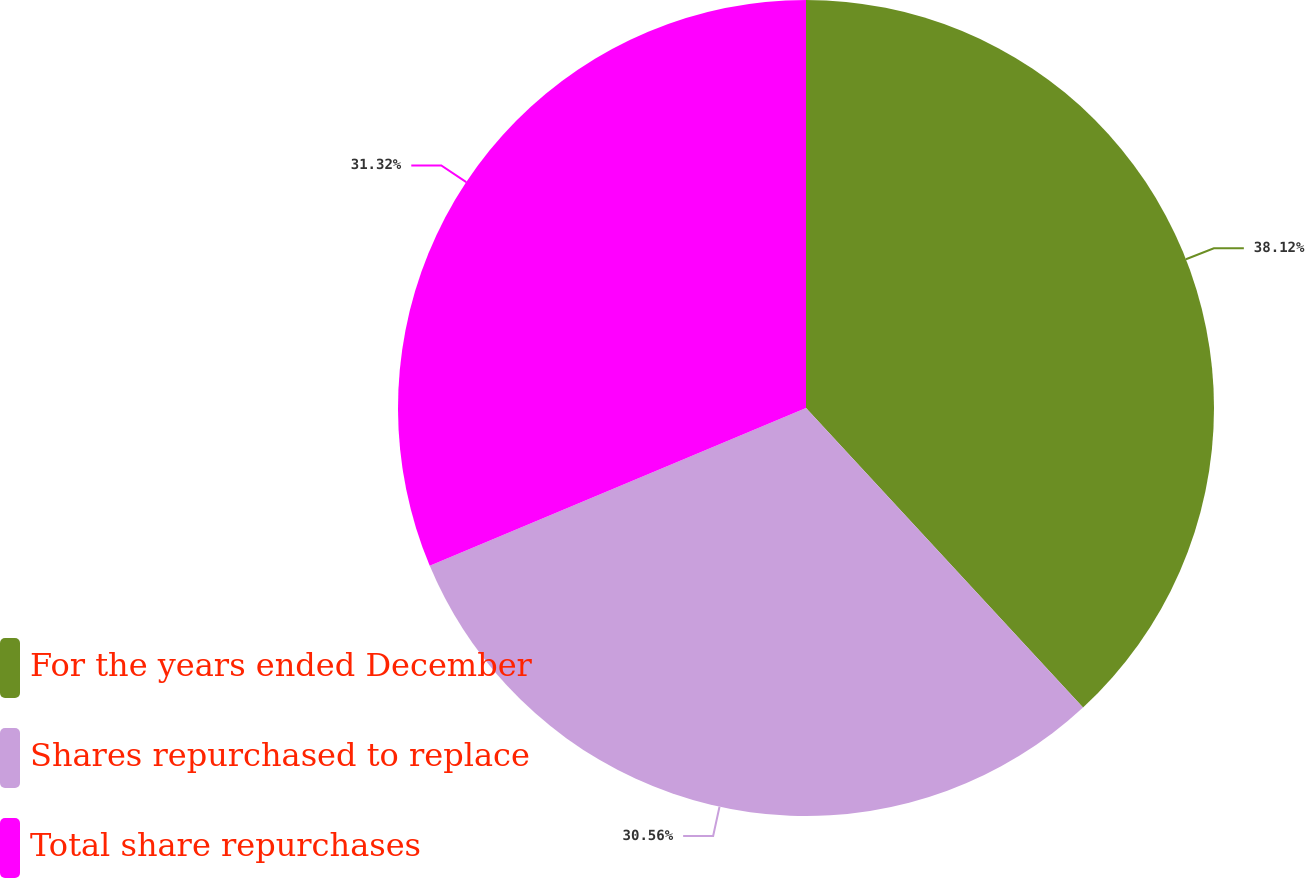Convert chart to OTSL. <chart><loc_0><loc_0><loc_500><loc_500><pie_chart><fcel>For the years ended December<fcel>Shares repurchased to replace<fcel>Total share repurchases<nl><fcel>38.12%<fcel>30.56%<fcel>31.32%<nl></chart> 